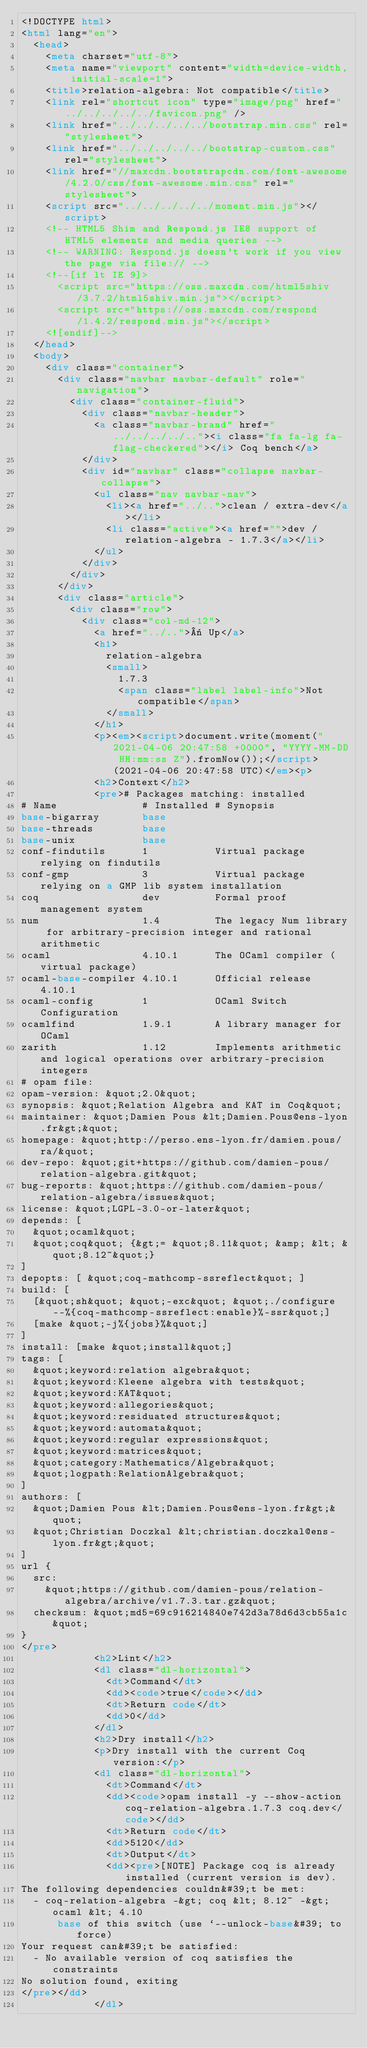Convert code to text. <code><loc_0><loc_0><loc_500><loc_500><_HTML_><!DOCTYPE html>
<html lang="en">
  <head>
    <meta charset="utf-8">
    <meta name="viewport" content="width=device-width, initial-scale=1">
    <title>relation-algebra: Not compatible</title>
    <link rel="shortcut icon" type="image/png" href="../../../../../favicon.png" />
    <link href="../../../../../bootstrap.min.css" rel="stylesheet">
    <link href="../../../../../bootstrap-custom.css" rel="stylesheet">
    <link href="//maxcdn.bootstrapcdn.com/font-awesome/4.2.0/css/font-awesome.min.css" rel="stylesheet">
    <script src="../../../../../moment.min.js"></script>
    <!-- HTML5 Shim and Respond.js IE8 support of HTML5 elements and media queries -->
    <!-- WARNING: Respond.js doesn't work if you view the page via file:// -->
    <!--[if lt IE 9]>
      <script src="https://oss.maxcdn.com/html5shiv/3.7.2/html5shiv.min.js"></script>
      <script src="https://oss.maxcdn.com/respond/1.4.2/respond.min.js"></script>
    <![endif]-->
  </head>
  <body>
    <div class="container">
      <div class="navbar navbar-default" role="navigation">
        <div class="container-fluid">
          <div class="navbar-header">
            <a class="navbar-brand" href="../../../../.."><i class="fa fa-lg fa-flag-checkered"></i> Coq bench</a>
          </div>
          <div id="navbar" class="collapse navbar-collapse">
            <ul class="nav navbar-nav">
              <li><a href="../..">clean / extra-dev</a></li>
              <li class="active"><a href="">dev / relation-algebra - 1.7.3</a></li>
            </ul>
          </div>
        </div>
      </div>
      <div class="article">
        <div class="row">
          <div class="col-md-12">
            <a href="../..">« Up</a>
            <h1>
              relation-algebra
              <small>
                1.7.3
                <span class="label label-info">Not compatible</span>
              </small>
            </h1>
            <p><em><script>document.write(moment("2021-04-06 20:47:58 +0000", "YYYY-MM-DD HH:mm:ss Z").fromNow());</script> (2021-04-06 20:47:58 UTC)</em><p>
            <h2>Context</h2>
            <pre># Packages matching: installed
# Name              # Installed # Synopsis
base-bigarray       base
base-threads        base
base-unix           base
conf-findutils      1           Virtual package relying on findutils
conf-gmp            3           Virtual package relying on a GMP lib system installation
coq                 dev         Formal proof management system
num                 1.4         The legacy Num library for arbitrary-precision integer and rational arithmetic
ocaml               4.10.1      The OCaml compiler (virtual package)
ocaml-base-compiler 4.10.1      Official release 4.10.1
ocaml-config        1           OCaml Switch Configuration
ocamlfind           1.9.1       A library manager for OCaml
zarith              1.12        Implements arithmetic and logical operations over arbitrary-precision integers
# opam file:
opam-version: &quot;2.0&quot;
synopsis: &quot;Relation Algebra and KAT in Coq&quot;
maintainer: &quot;Damien Pous &lt;Damien.Pous@ens-lyon.fr&gt;&quot;
homepage: &quot;http://perso.ens-lyon.fr/damien.pous/ra/&quot;
dev-repo: &quot;git+https://github.com/damien-pous/relation-algebra.git&quot;
bug-reports: &quot;https://github.com/damien-pous/relation-algebra/issues&quot;
license: &quot;LGPL-3.0-or-later&quot;
depends: [
  &quot;ocaml&quot;
  &quot;coq&quot; {&gt;= &quot;8.11&quot; &amp; &lt; &quot;8.12~&quot;}
]
depopts: [ &quot;coq-mathcomp-ssreflect&quot; ]
build: [
  [&quot;sh&quot; &quot;-exc&quot; &quot;./configure --%{coq-mathcomp-ssreflect:enable}%-ssr&quot;]
  [make &quot;-j%{jobs}%&quot;]
]
install: [make &quot;install&quot;]
tags: [
  &quot;keyword:relation algebra&quot;
  &quot;keyword:Kleene algebra with tests&quot;
  &quot;keyword:KAT&quot;
  &quot;keyword:allegories&quot;
  &quot;keyword:residuated structures&quot;
  &quot;keyword:automata&quot;
  &quot;keyword:regular expressions&quot;
  &quot;keyword:matrices&quot;
  &quot;category:Mathematics/Algebra&quot;
  &quot;logpath:RelationAlgebra&quot;
]
authors: [
  &quot;Damien Pous &lt;Damien.Pous@ens-lyon.fr&gt;&quot;
  &quot;Christian Doczkal &lt;christian.doczkal@ens-lyon.fr&gt;&quot;
]
url {
  src:
    &quot;https://github.com/damien-pous/relation-algebra/archive/v1.7.3.tar.gz&quot;
  checksum: &quot;md5=69c916214840e742d3a78d6d3cb55a1c&quot;
}
</pre>
            <h2>Lint</h2>
            <dl class="dl-horizontal">
              <dt>Command</dt>
              <dd><code>true</code></dd>
              <dt>Return code</dt>
              <dd>0</dd>
            </dl>
            <h2>Dry install</h2>
            <p>Dry install with the current Coq version:</p>
            <dl class="dl-horizontal">
              <dt>Command</dt>
              <dd><code>opam install -y --show-action coq-relation-algebra.1.7.3 coq.dev</code></dd>
              <dt>Return code</dt>
              <dd>5120</dd>
              <dt>Output</dt>
              <dd><pre>[NOTE] Package coq is already installed (current version is dev).
The following dependencies couldn&#39;t be met:
  - coq-relation-algebra -&gt; coq &lt; 8.12~ -&gt; ocaml &lt; 4.10
      base of this switch (use `--unlock-base&#39; to force)
Your request can&#39;t be satisfied:
  - No available version of coq satisfies the constraints
No solution found, exiting
</pre></dd>
            </dl></code> 